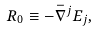Convert formula to latex. <formula><loc_0><loc_0><loc_500><loc_500>R _ { 0 } \equiv - \bar { \nabla } ^ { j } E _ { j } ,</formula> 